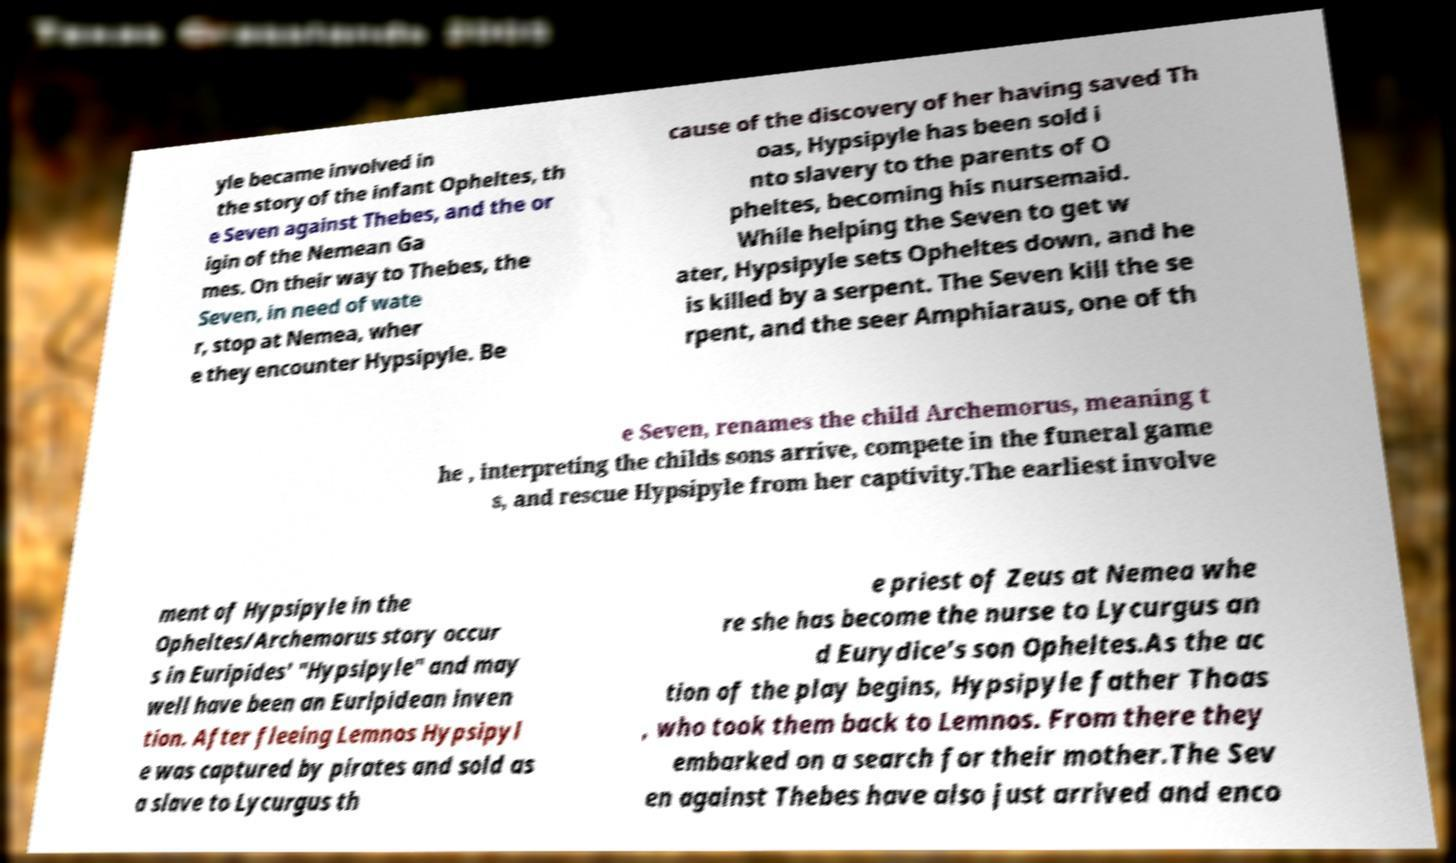There's text embedded in this image that I need extracted. Can you transcribe it verbatim? yle became involved in the story of the infant Opheltes, th e Seven against Thebes, and the or igin of the Nemean Ga mes. On their way to Thebes, the Seven, in need of wate r, stop at Nemea, wher e they encounter Hypsipyle. Be cause of the discovery of her having saved Th oas, Hypsipyle has been sold i nto slavery to the parents of O pheltes, becoming his nursemaid. While helping the Seven to get w ater, Hypsipyle sets Opheltes down, and he is killed by a serpent. The Seven kill the se rpent, and the seer Amphiaraus, one of th e Seven, renames the child Archemorus, meaning t he , interpreting the childs sons arrive, compete in the funeral game s, and rescue Hypsipyle from her captivity.The earliest involve ment of Hypsipyle in the Opheltes/Archemorus story occur s in Euripides' "Hypsipyle" and may well have been an Euripidean inven tion. After fleeing Lemnos Hypsipyl e was captured by pirates and sold as a slave to Lycurgus th e priest of Zeus at Nemea whe re she has become the nurse to Lycurgus an d Eurydice's son Opheltes.As the ac tion of the play begins, Hypsipyle father Thoas , who took them back to Lemnos. From there they embarked on a search for their mother.The Sev en against Thebes have also just arrived and enco 